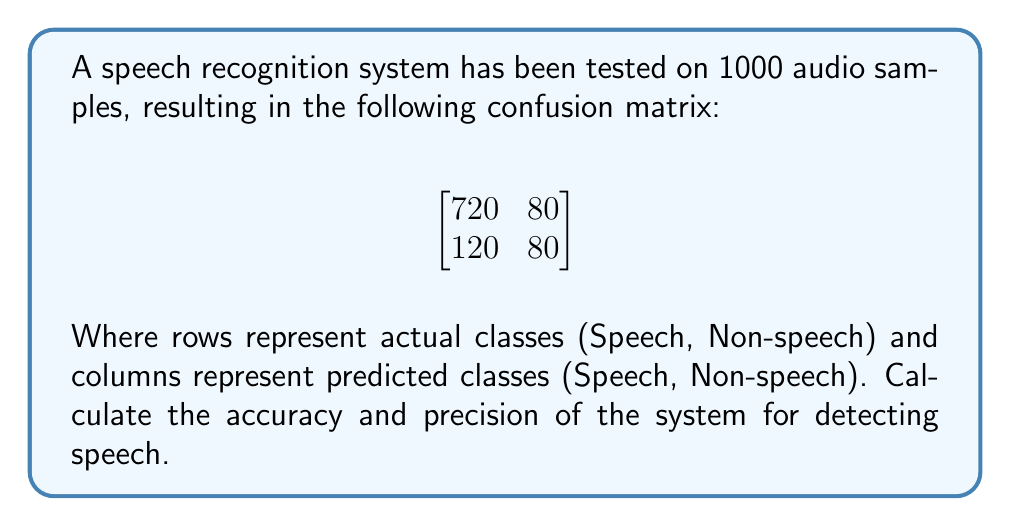Could you help me with this problem? To calculate accuracy and precision, we need to understand the confusion matrix:

True Positives (TP) = 720 (correctly identified speech)
False Positives (FP) = 120 (non-speech misclassified as speech)
False Negatives (FN) = 80 (speech misclassified as non-speech)
True Negatives (TN) = 80 (correctly identified non-speech)

Step 1: Calculate Accuracy
Accuracy is the proportion of correct predictions (both true positives and true negatives) among the total number of cases examined.

$$ \text{Accuracy} = \frac{TP + TN}{TP + TN + FP + FN} $$

$$ \text{Accuracy} = \frac{720 + 80}{720 + 80 + 120 + 80} = \frac{800}{1000} = 0.8 \text{ or } 80\% $$

Step 2: Calculate Precision
Precision is the proportion of correct positive identifications.

$$ \text{Precision} = \frac{TP}{TP + FP} $$

$$ \text{Precision} = \frac{720}{720 + 120} = \frac{720}{840} \approx 0.8571 \text{ or } 85.71\% $$

Therefore, the accuracy of the speech recognition system is 80%, and its precision for detecting speech is approximately 85.71%.
Answer: Accuracy: 80%, Precision: 85.71% 